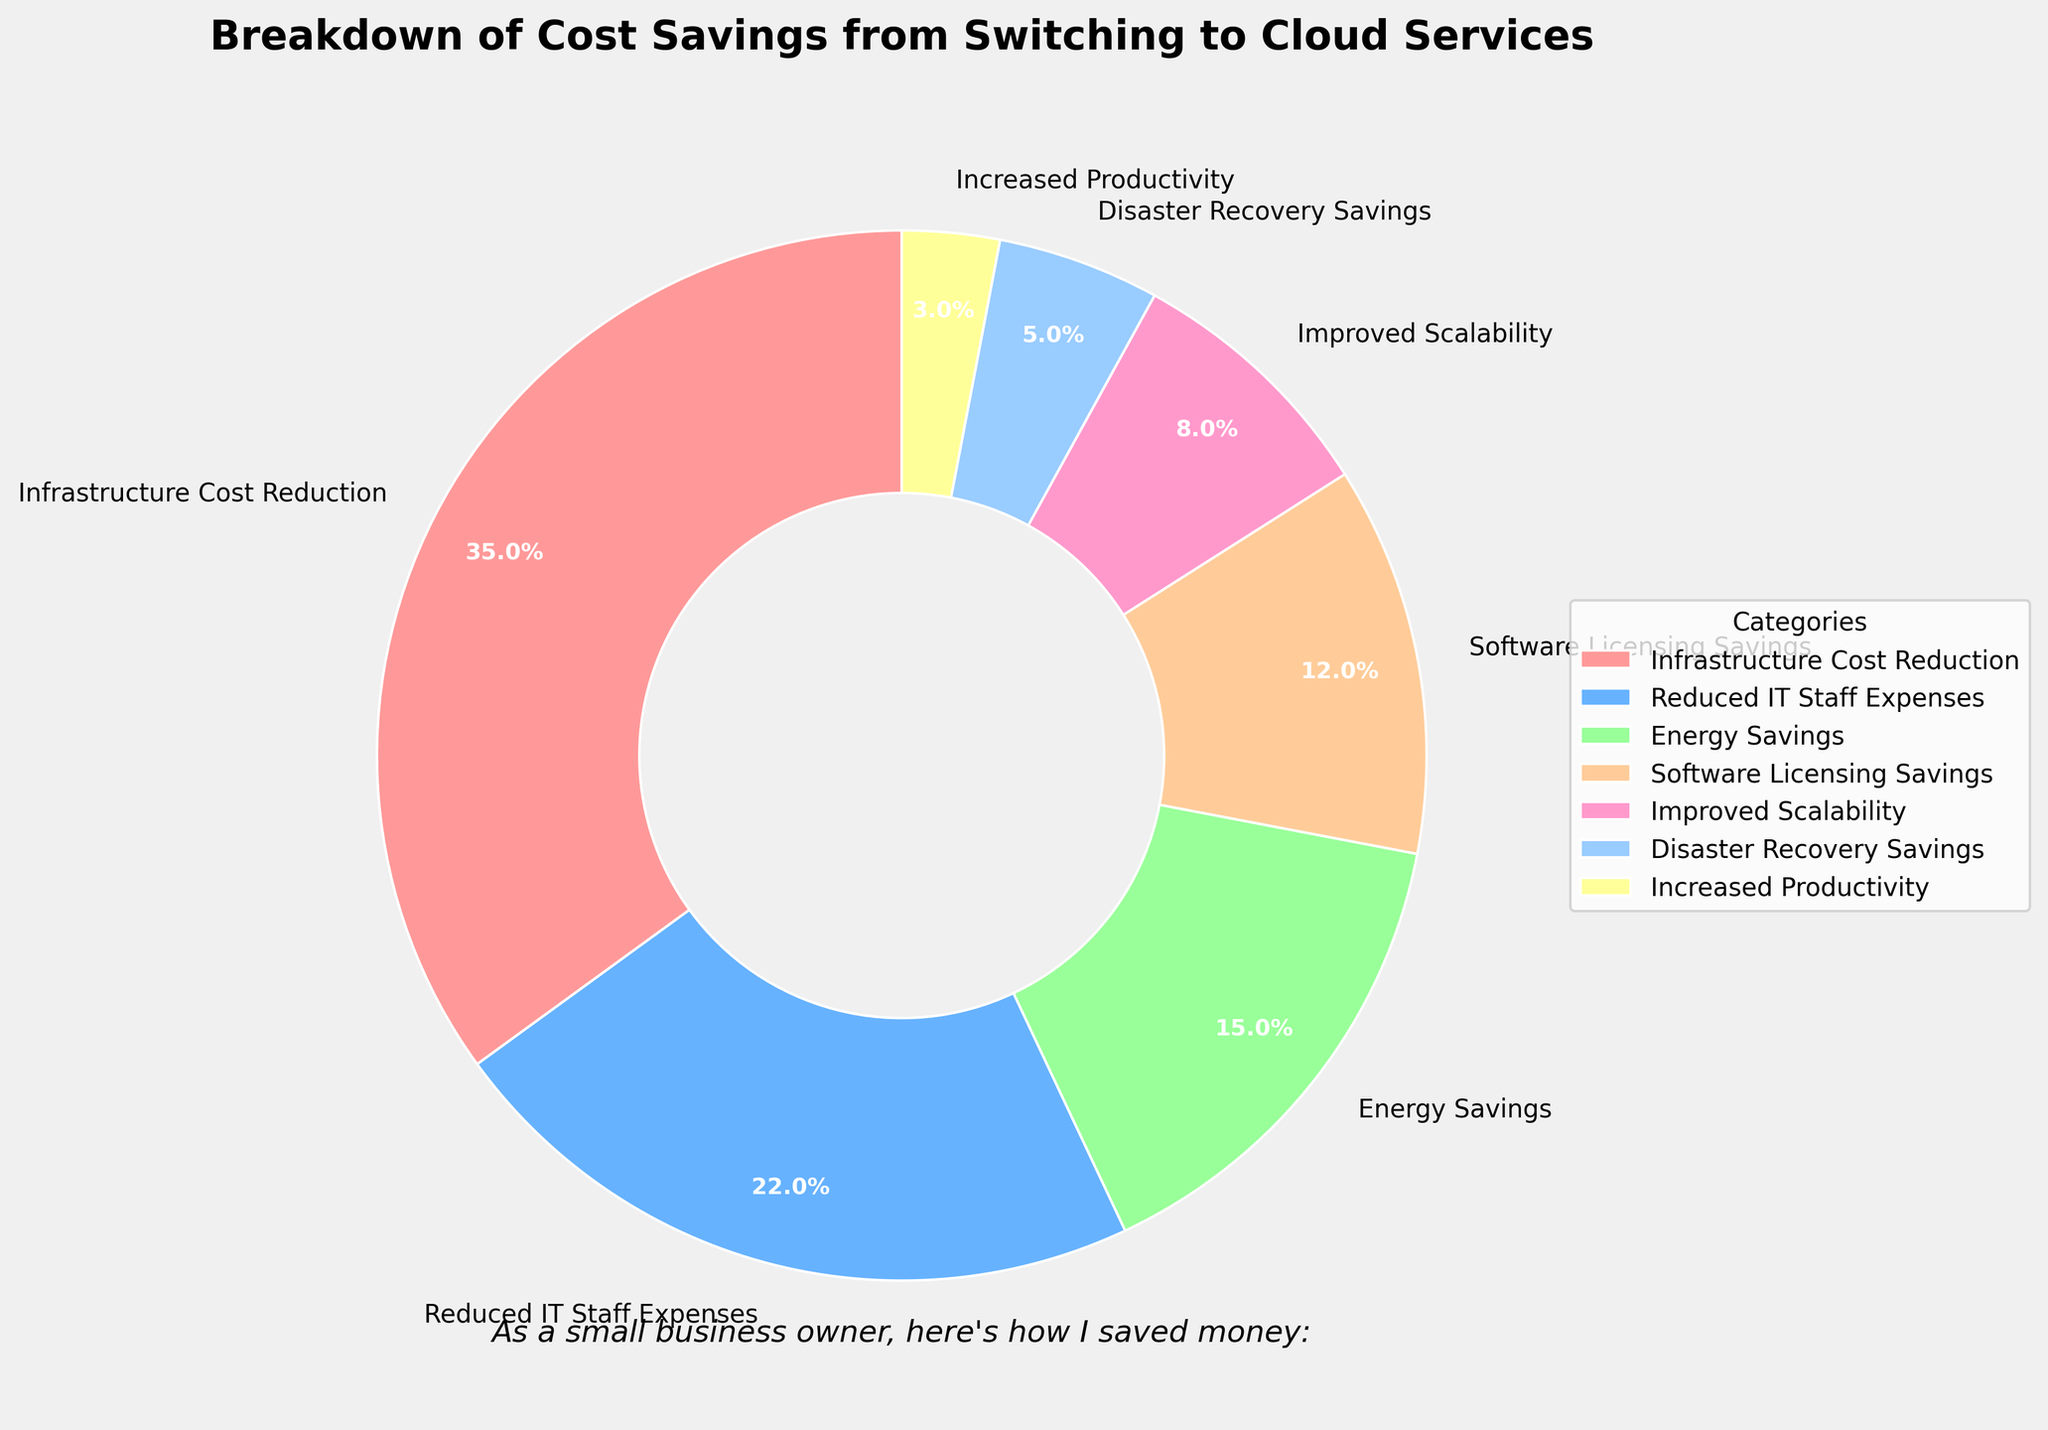What's the category with the largest percentage in cost savings? Identify the largest percentage value on the pie chart, which is 35%. The category associated with this percentage is Infrastructure Cost Reduction.
Answer: Infrastructure Cost Reduction How much higher is Infrastructure Cost Reduction compared to Reduced IT Staff Expenses? Subtract the percentage of Reduced IT Staff Expenses (22%) from the percentage of Infrastructure Cost Reduction (35%). 35% - 22% = 13%.
Answer: 13% Adding which two categories yields a percentage close to that of Infrastructure Cost Reduction? Identify categories whose percentages add up to 35. The percentages for Energy Savings (15%) and Reduced IT Staff Expenses (22%) sum up to 37, which is close to 35%.
Answer: Energy Savings and Reduced IT Staff Expenses Which category has the lowest percentage in cost savings? Identify the smallest percentage value on the pie chart, which is 3%. The category associated with this percentage is Increased Productivity.
Answer: Increased Productivity Combining the percentages of Software Licensing Savings and Disaster Recovery Savings gives what total percentage? Add the percentages of Software Licensing Savings (12%) and Disaster Recovery Savings (5%). 12% + 5% = 17%.
Answer: 17% Rank the categories in descending order based on their percentage. List the percentages in descending order: Infrastructure Cost Reduction (35%), Reduced IT Staff Expenses (22%), Energy Savings (15%), Software Licensing Savings (12%), Improved Scalability (8%), Disaster Recovery Savings (5%), Increased Productivity (3%).
Answer: Infrastructure Cost Reduction, Reduced IT Staff Expenses, Energy Savings, Software Licensing Savings, Improved Scalability, Disaster Recovery Savings, Increased Productivity Is the percentage for Energy Savings higher than Software Licensing Savings? Compare the two percentages: Energy Savings (15%) is greater than Software Licensing Savings (12%).
Answer: Yes What is the combined percentage of Improved Scalability, Disaster Recovery Savings, and Increased Productivity? Add the percentages of Improved Scalability (8%), Disaster Recovery Savings (5%), and Increased Productivity (3%). 8% + 5% + 3% = 16%.
Answer: 16% If you combine the three smallest categories, what percentage of total savings do they account for? Add the percentages of the three smallest categories: Increased Productivity (3%), Disaster Recovery Savings (5%), and Improved Scalability (8%). 3% + 5% + 8% = 16%.
Answer: 16% Which categories have a combined percentage higher than Reduced IT Staff Expenses? Identify the categories whose combined percentage is higher than 22%. Combined, Energy Savings (15%) and Software Licensing Savings (12%) give 27% which is higher.
Answer: Energy Savings and Software Licensing Savings 